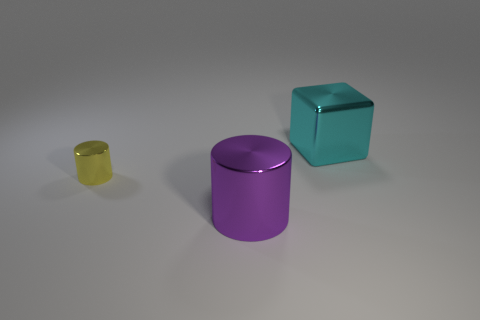How many other objects have the same color as the small shiny object?
Offer a terse response. 0. Is the color of the large shiny cube the same as the tiny metallic thing?
Provide a short and direct response. No. What material is the thing that is behind the tiny yellow cylinder?
Provide a succinct answer. Metal. How many large objects are metallic cylinders or metallic cubes?
Your answer should be compact. 2. Is there a big cyan object made of the same material as the yellow cylinder?
Ensure brevity in your answer.  Yes. There is a shiny cylinder left of the purple metallic cylinder; does it have the same size as the large cyan block?
Offer a terse response. No. Is there a small yellow shiny thing on the left side of the cylinder on the left side of the large metallic thing in front of the tiny thing?
Your answer should be very brief. No. How many metal objects are large objects or purple objects?
Your answer should be very brief. 2. What number of other things are the same shape as the tiny object?
Keep it short and to the point. 1. Is the number of purple metal cylinders greater than the number of tiny gray cylinders?
Your answer should be compact. Yes. 